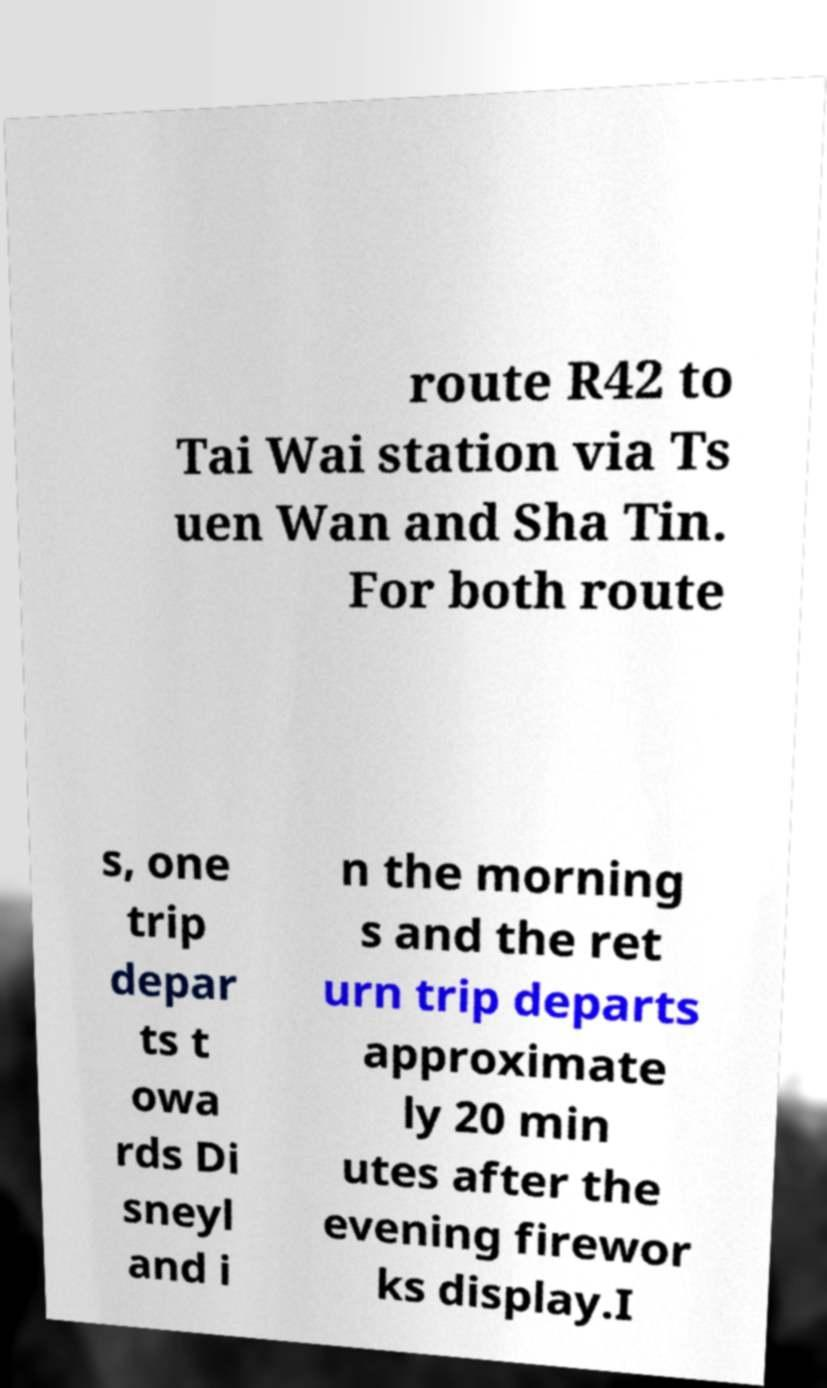What messages or text are displayed in this image? I need them in a readable, typed format. route R42 to Tai Wai station via Ts uen Wan and Sha Tin. For both route s, one trip depar ts t owa rds Di sneyl and i n the morning s and the ret urn trip departs approximate ly 20 min utes after the evening firewor ks display.I 